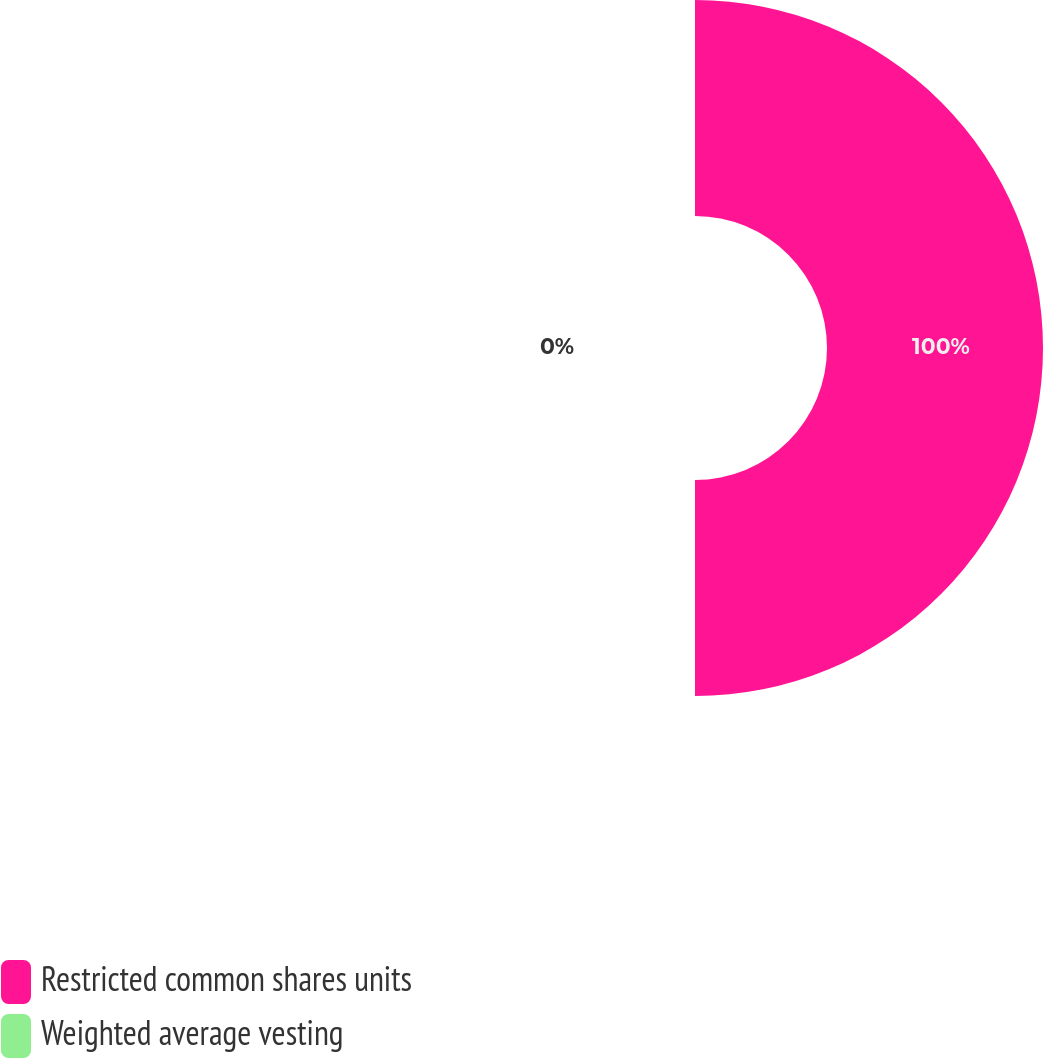<chart> <loc_0><loc_0><loc_500><loc_500><pie_chart><fcel>Restricted common shares units<fcel>Weighted average vesting<nl><fcel>100.0%<fcel>0.0%<nl></chart> 